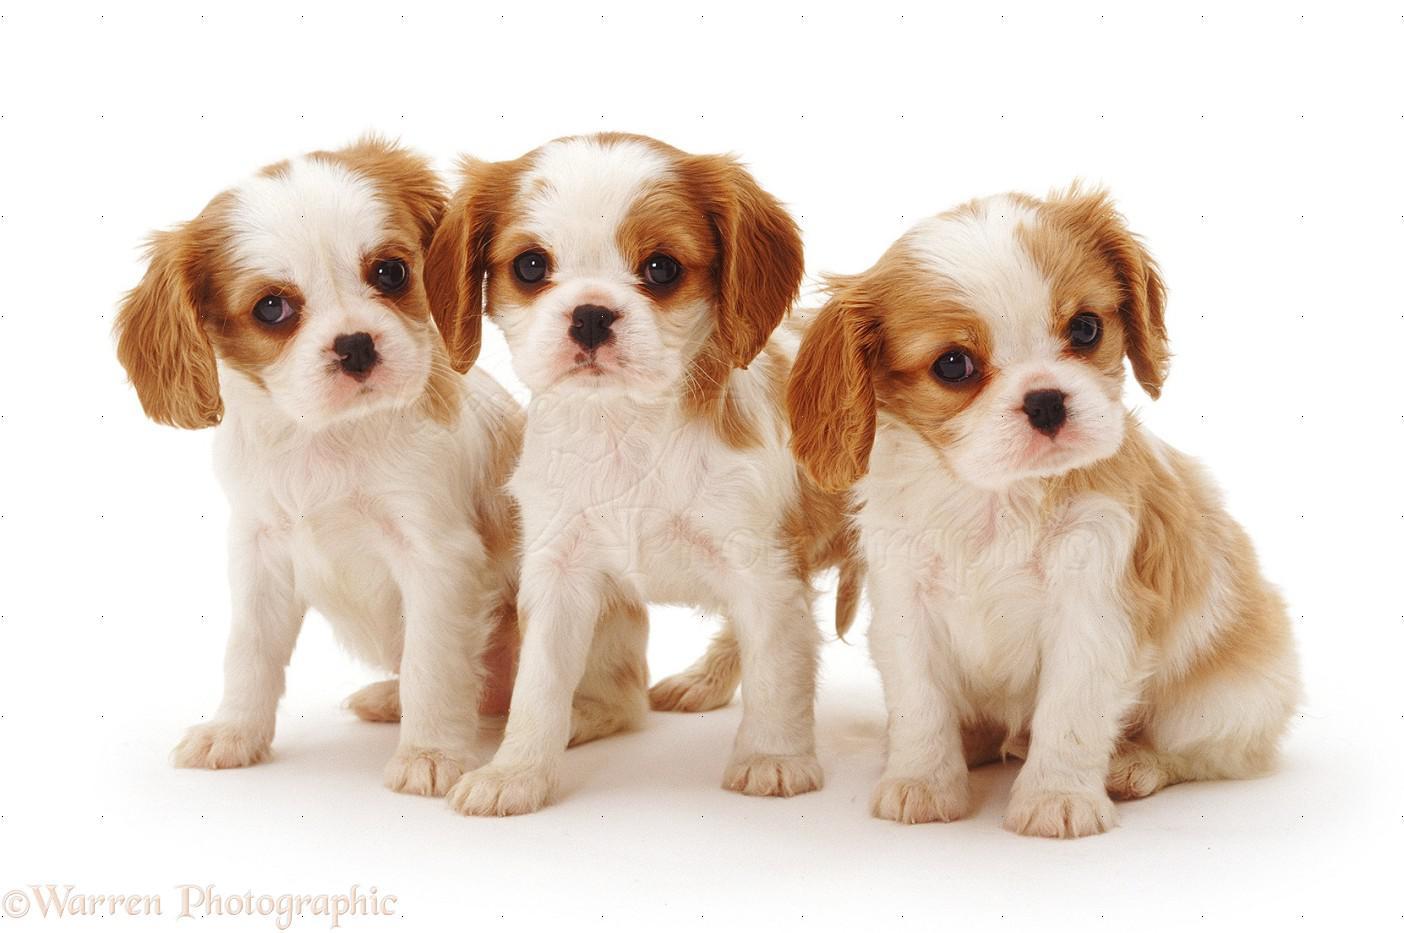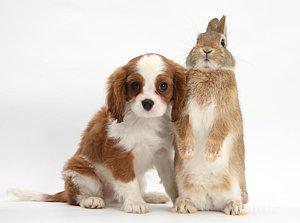The first image is the image on the left, the second image is the image on the right. For the images displayed, is the sentence "Each image has one dog." factually correct? Answer yes or no. No. 